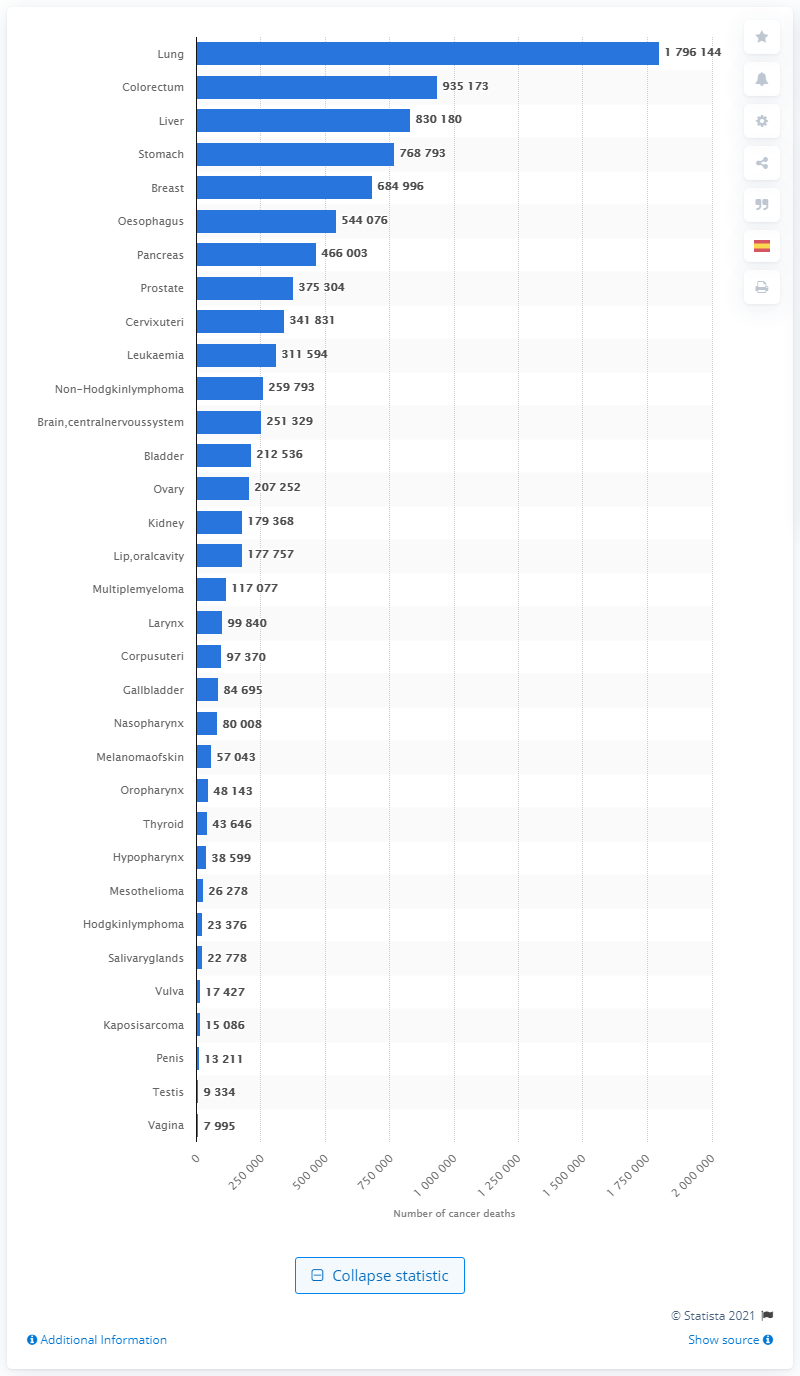Outline some significant characteristics in this image. In 2020, an estimated 179,6144 people died from lung cancer. 